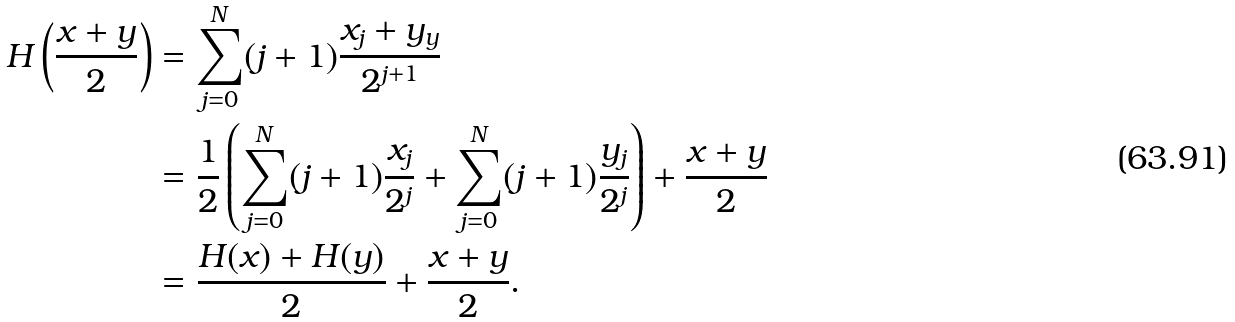<formula> <loc_0><loc_0><loc_500><loc_500>H \left ( \frac { x + y } { 2 } \right ) & = \sum _ { j = 0 } ^ { N } ( j + 1 ) \frac { x _ { j } + y _ { y } } { 2 ^ { j + 1 } } \\ & = \frac { 1 } { 2 } \left ( \sum _ { j = 0 } ^ { N } ( j + 1 ) \frac { x _ { j } } { 2 ^ { j } } + \sum _ { j = 0 } ^ { N } ( j + 1 ) \frac { y _ { j } } { 2 ^ { j } } \right ) + \frac { x + y } { 2 } \\ & = \frac { H ( x ) + H ( y ) } { 2 } + \frac { x + y } { 2 } .</formula> 